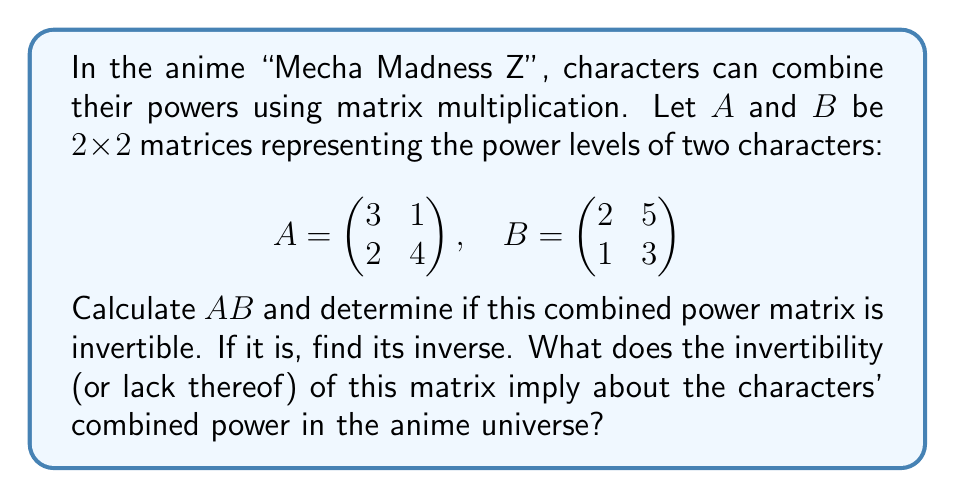Solve this math problem. Okay, let's break this down step-by-step:

1) First, we need to calculate $AB$. Remember, for matrix multiplication:
   $$(AB)_{ij} = \sum_{k=1}^n A_{ik}B_{kj}$$

   $$AB = \begin{pmatrix} 3(2)+1(1) & 3(5)+1(3) \\ 2(2)+4(1) & 2(5)+4(3) \end{pmatrix}$$
   
   $$AB = \begin{pmatrix} 7 & 18 \\ 8 & 22 \end{pmatrix}$$

2) To determine if this matrix is invertible, we calculate its determinant:

   $$\det(AB) = 7(22) - 18(8) = 154 - 144 = 10$$

   Since the determinant is non-zero, the matrix is invertible.

3) To find the inverse, we use the formula:

   $$(AB)^{-1} = \frac{1}{\det(AB)} \begin{pmatrix} d & -b \\ -c & a \end{pmatrix}$$

   where $AB = \begin{pmatrix} a & b \\ c & d \end{pmatrix}$

   So, $$(AB)^{-1} = \frac{1}{10} \begin{pmatrix} 22 & -18 \\ -8 & 7 \end{pmatrix}$$

4) In the context of the anime, invertibility implies that the combined power can be "undone" or reversed. The inverse matrix could represent a way to separate the combined powers back into their original forms.
Answer: $AB = \begin{pmatrix} 7 & 18 \\ 8 & 22 \end{pmatrix}$

The matrix is invertible.

$(AB)^{-1} = \frac{1}{10} \begin{pmatrix} 22 & -18 \\ -8 & 7 \end{pmatrix}$

Invertibility implies the combined power transformation is reversible in the anime universe. 